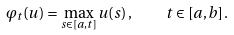Convert formula to latex. <formula><loc_0><loc_0><loc_500><loc_500>\varphi _ { t } ( u ) = \max _ { s \in [ a , t ] } u ( s ) \, , \quad t \in [ a , b ] \, .</formula> 